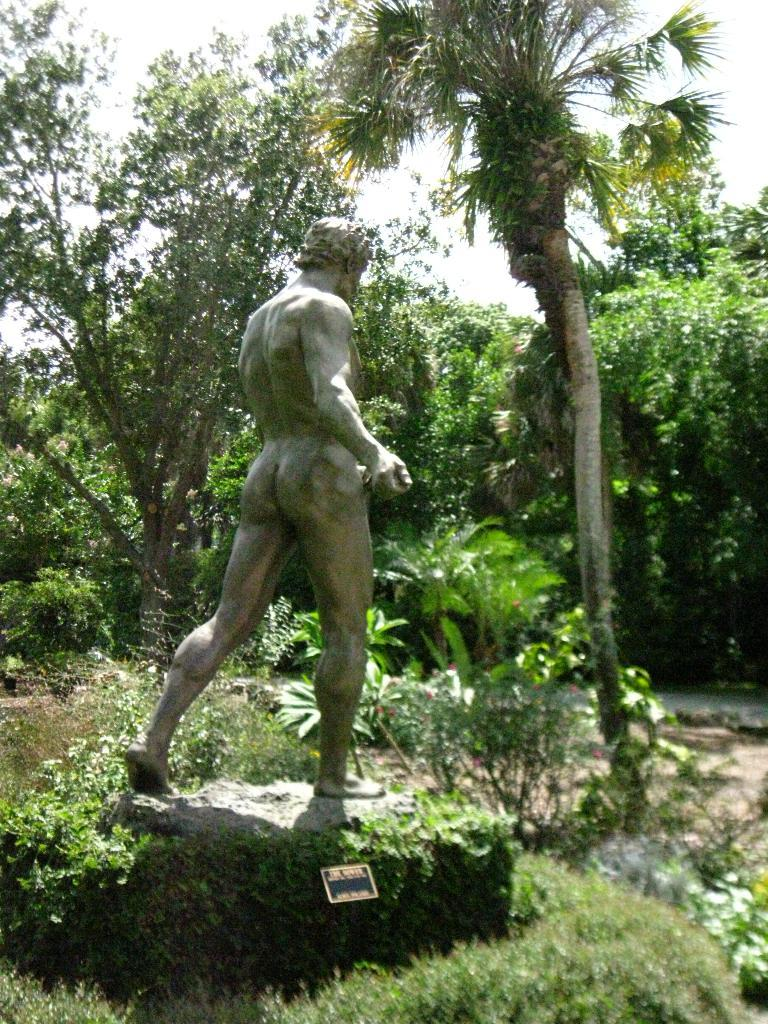What is the main subject of the image? There is a statue of a man in the image. What is the statue standing on? The statue is standing on a rock. What can be seen in the background of the image? There are many trees surrounding the statue. What type of insect is crawling on the statue's arm in the image? There is no insect visible on the statue's arm in the image. 